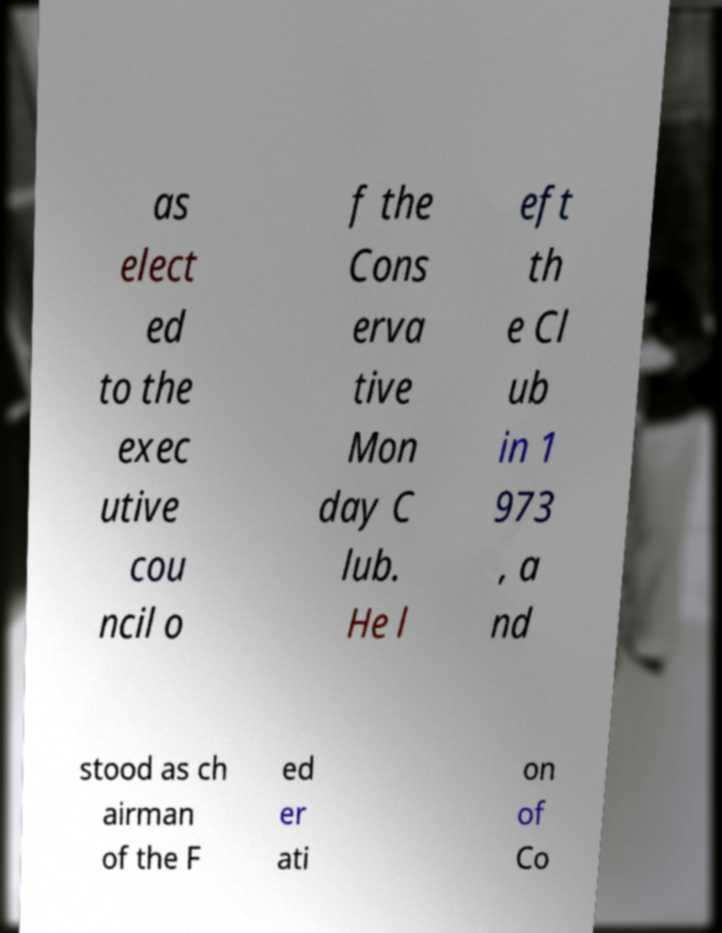Can you accurately transcribe the text from the provided image for me? as elect ed to the exec utive cou ncil o f the Cons erva tive Mon day C lub. He l eft th e Cl ub in 1 973 , a nd stood as ch airman of the F ed er ati on of Co 